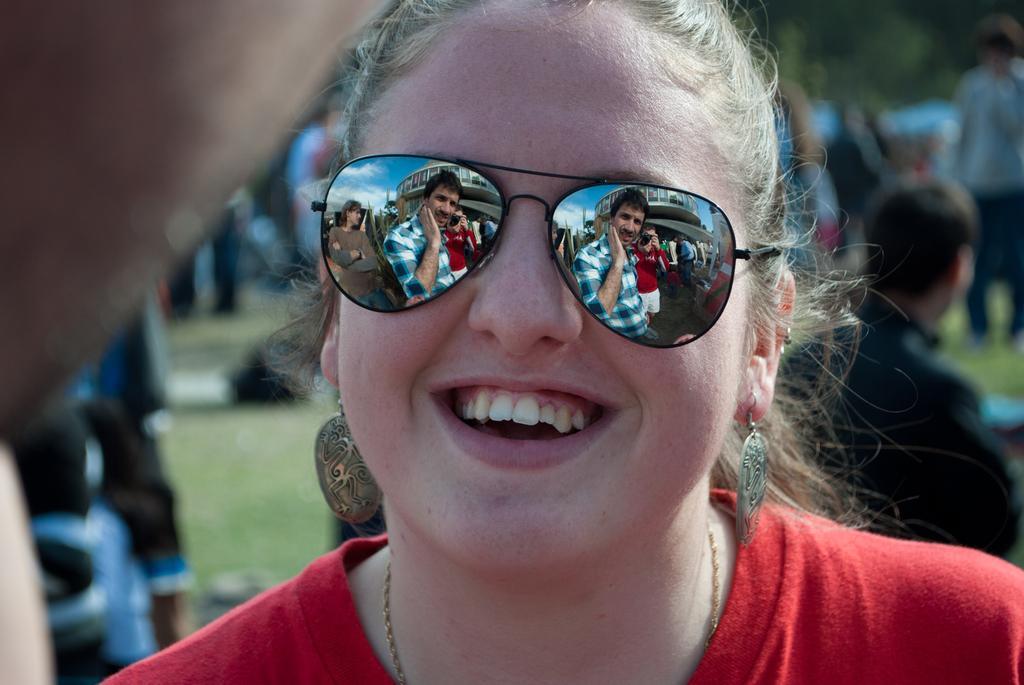How would you summarize this image in a sentence or two? There is one women wearing a goggles in the middle of this image. There are some other persons in the background. We can see there is a reflection of some persons in her goggles. 